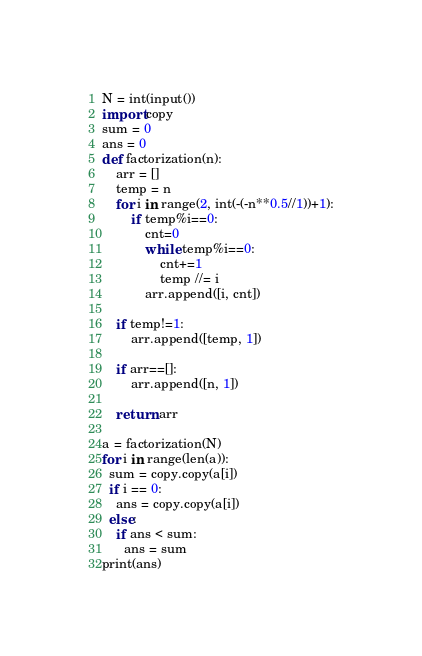Convert code to text. <code><loc_0><loc_0><loc_500><loc_500><_Python_>N = int(input())
import copy
sum = 0
ans = 0
def factorization(n):
    arr = []
    temp = n
    for i in range(2, int(-(-n**0.5//1))+1):
        if temp%i==0:
            cnt=0
            while temp%i==0:
                cnt+=1
                temp //= i
            arr.append([i, cnt])

    if temp!=1:
        arr.append([temp, 1])

    if arr==[]:
        arr.append([n, 1])

    return arr

a = factorization(N)
for i in range(len(a)):
  sum = copy.copy(a[i])
  if i == 0:
    ans = copy.copy(a[i])
  else:
    if ans < sum:
      ans = sum
print(ans)</code> 